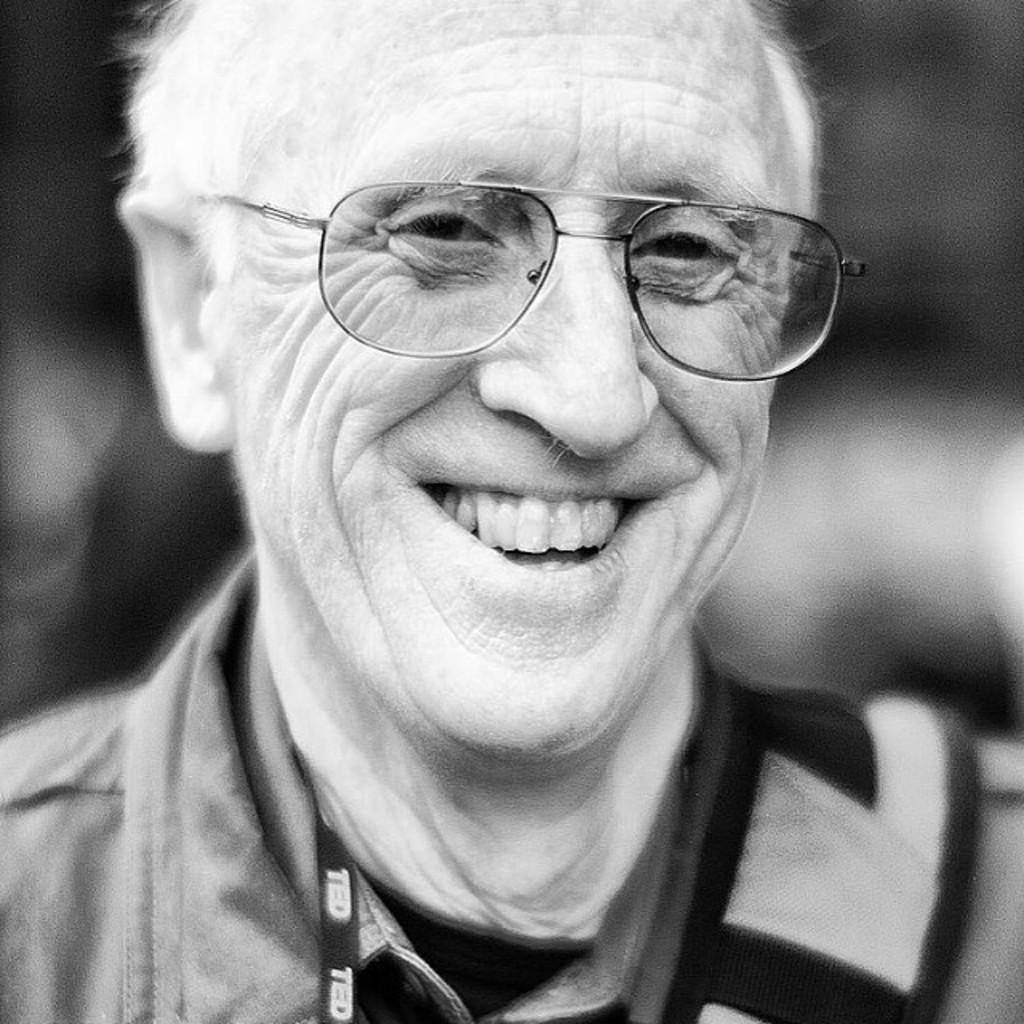How would you summarize this image in a sentence or two? In this image I can see an old man smiling, wearing an id card and spectacles. The background is blurred and this is a black and white image. 